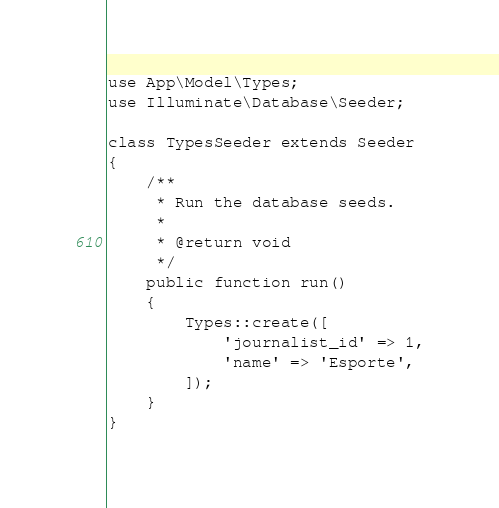<code> <loc_0><loc_0><loc_500><loc_500><_PHP_>use App\Model\Types;
use Illuminate\Database\Seeder;

class TypesSeeder extends Seeder
{
    /**
     * Run the database seeds.
     *
     * @return void
     */
    public function run()
    {
        Types::create([
            'journalist_id' => 1,
            'name' => 'Esporte',
        ]);
    }
}

</code> 